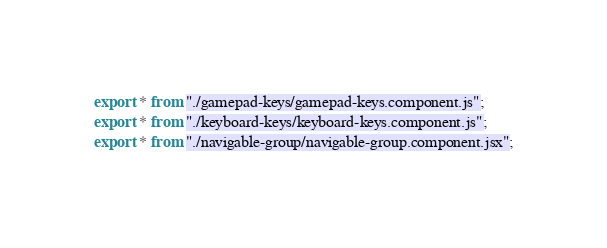Convert code to text. <code><loc_0><loc_0><loc_500><loc_500><_TypeScript_>export * from "./gamepad-keys/gamepad-keys.component.js";
export * from "./keyboard-keys/keyboard-keys.component.js";
export * from "./navigable-group/navigable-group.component.jsx";
</code> 